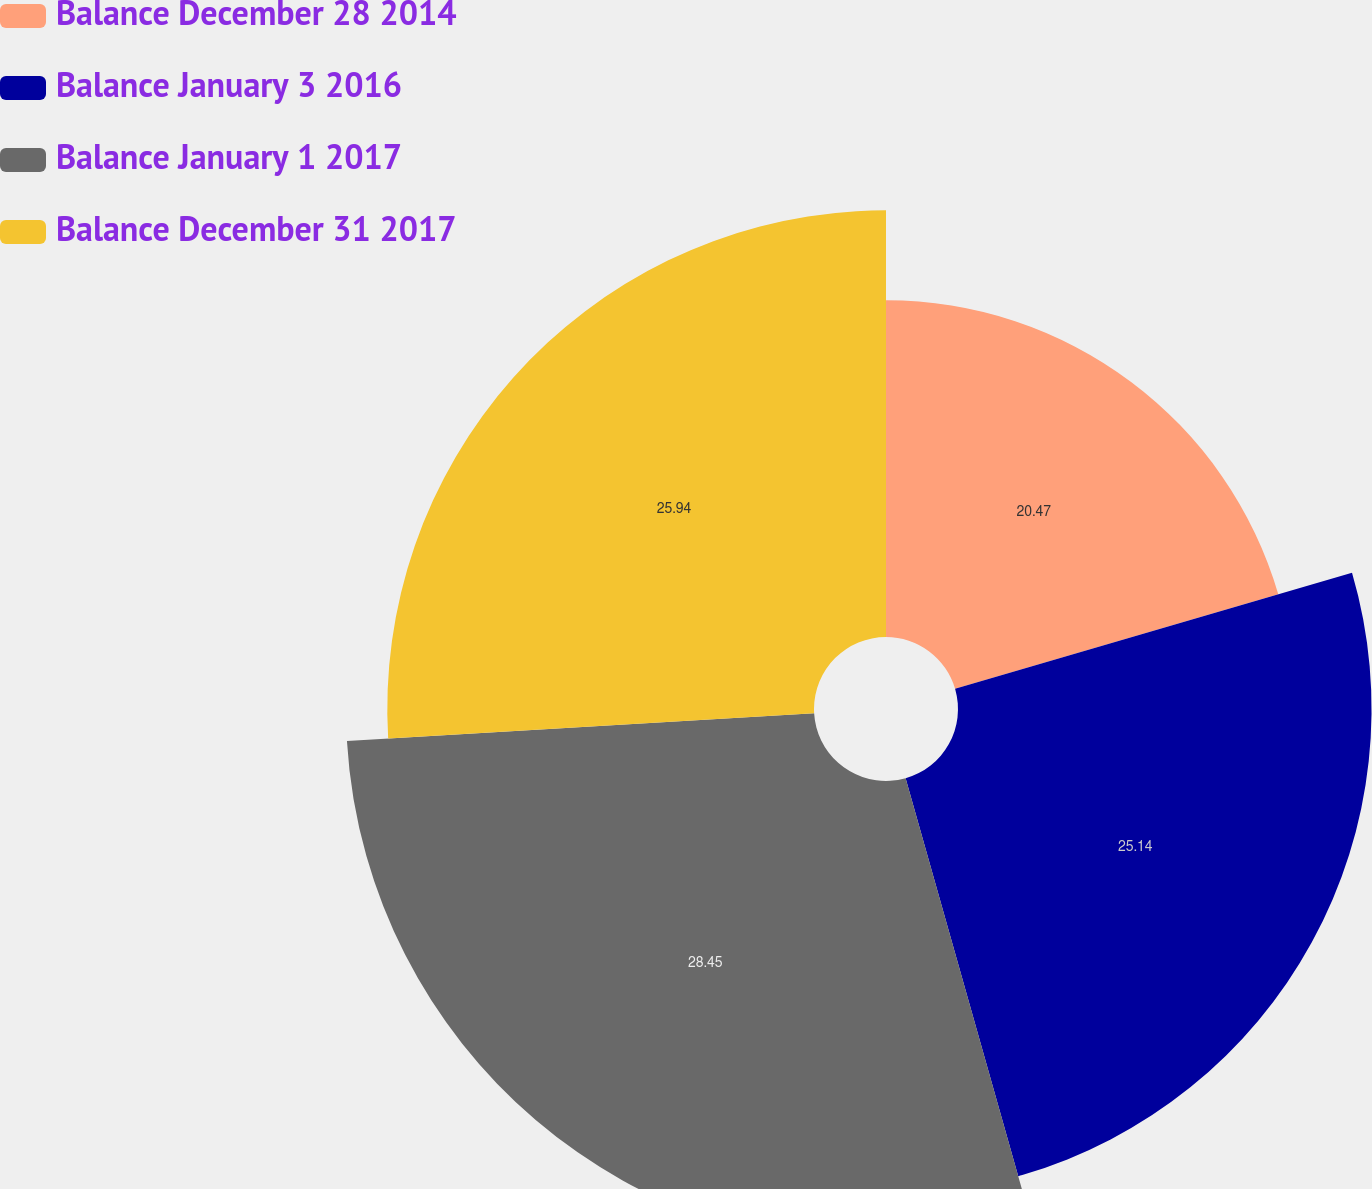Convert chart. <chart><loc_0><loc_0><loc_500><loc_500><pie_chart><fcel>Balance December 28 2014<fcel>Balance January 3 2016<fcel>Balance January 1 2017<fcel>Balance December 31 2017<nl><fcel>20.47%<fcel>25.14%<fcel>28.45%<fcel>25.94%<nl></chart> 